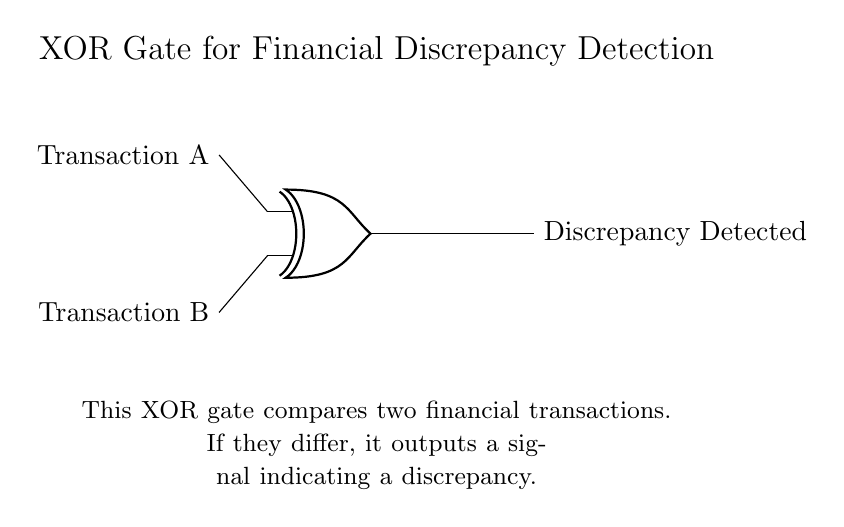What is the function of this circuit? The circuit uses an XOR gate, which outputs a signal when the two input transactions differ.
Answer: Discrepancy detection How many inputs does the XOR gate have? XOR gates have exactly two inputs, which are labeled as Transaction A and Transaction B in this circuit.
Answer: Two inputs What will the output be if both transactions are the same? In this XOR configuration, if both Transaction A and Transaction B are identical, the output will not indicate a discrepancy since the rule of XOR is that it only outputs a high signal when the inputs differ.
Answer: No discrepancy What do the two inputs represent? The inputs of the XOR gate are labeled as Transaction A and Transaction B, which represent two financial transactions being compared for differences.
Answer: Financial transactions What happens if one transaction is different? If one transaction differs from the other, the XOR gate will output a signal indicating a discrepancy due to the nature of how XOR operates, which is to signal high if the inputs are not equal.
Answer: Signal discrepancy What does the output signify? The output signals that there is a discrepancy detected between the two transactions being compared by the XOR gate, highlighting a potential issue in the financial data.
Answer: Discrepancy detected 